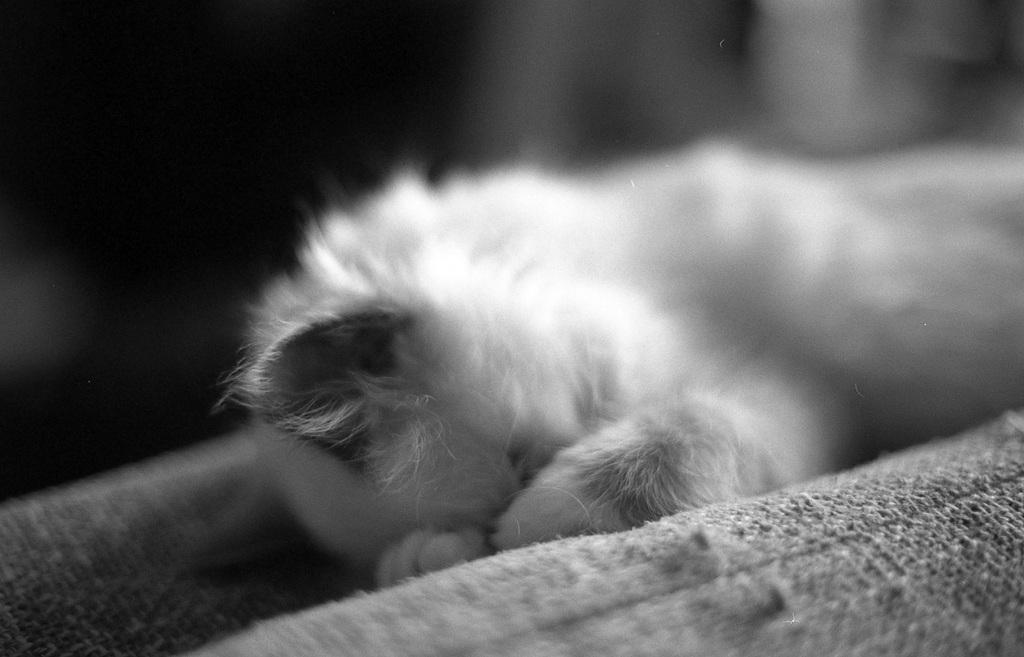What is the color scheme of the image? The image is black and white. What can be seen in the image besides the color scheme? There is an animal in the image. What is the animal doing in the image? The animal is sleeping on a bed. What type of horn can be seen on the animal's chin in the image? There is no horn or chin visible on the animal in the image, as it is sleeping on a bed. 